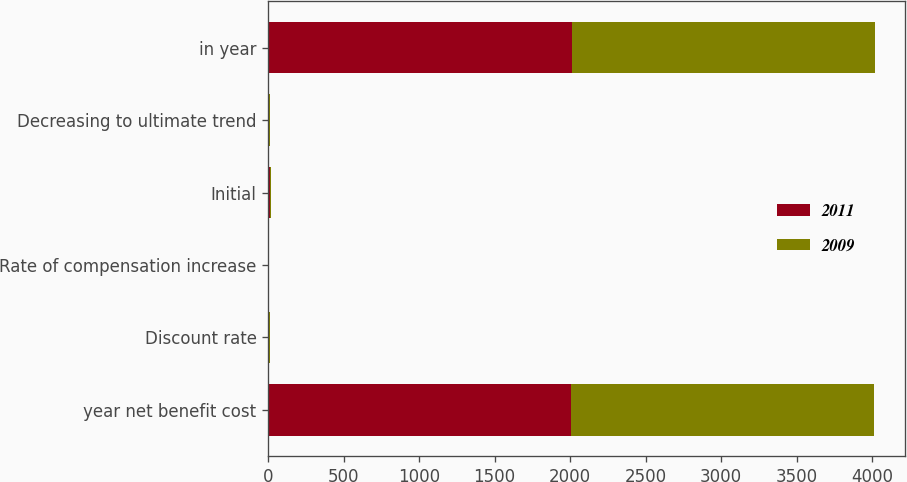Convert chart to OTSL. <chart><loc_0><loc_0><loc_500><loc_500><stacked_bar_chart><ecel><fcel>year net benefit cost<fcel>Discount rate<fcel>Rate of compensation increase<fcel>Initial<fcel>Decreasing to ultimate trend<fcel>in year<nl><fcel>2011<fcel>2007<fcel>5.86<fcel>3.75<fcel>9<fcel>5<fcel>2011<nl><fcel>2009<fcel>2006<fcel>5.62<fcel>3.75<fcel>8<fcel>5<fcel>2009<nl></chart> 